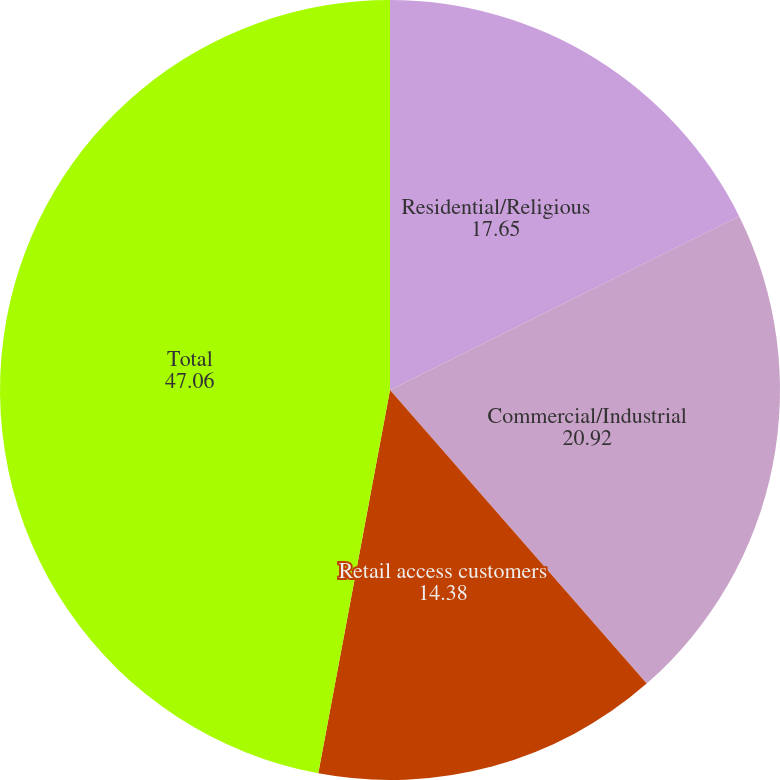Convert chart to OTSL. <chart><loc_0><loc_0><loc_500><loc_500><pie_chart><fcel>Residential/Religious<fcel>Commercial/Industrial<fcel>Retail access customers<fcel>Total<nl><fcel>17.65%<fcel>20.92%<fcel>14.38%<fcel>47.06%<nl></chart> 